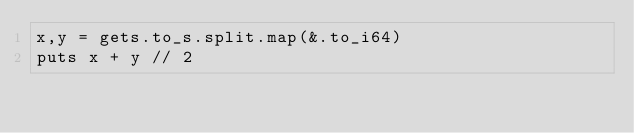Convert code to text. <code><loc_0><loc_0><loc_500><loc_500><_Crystal_>x,y = gets.to_s.split.map(&.to_i64)
puts x + y // 2</code> 